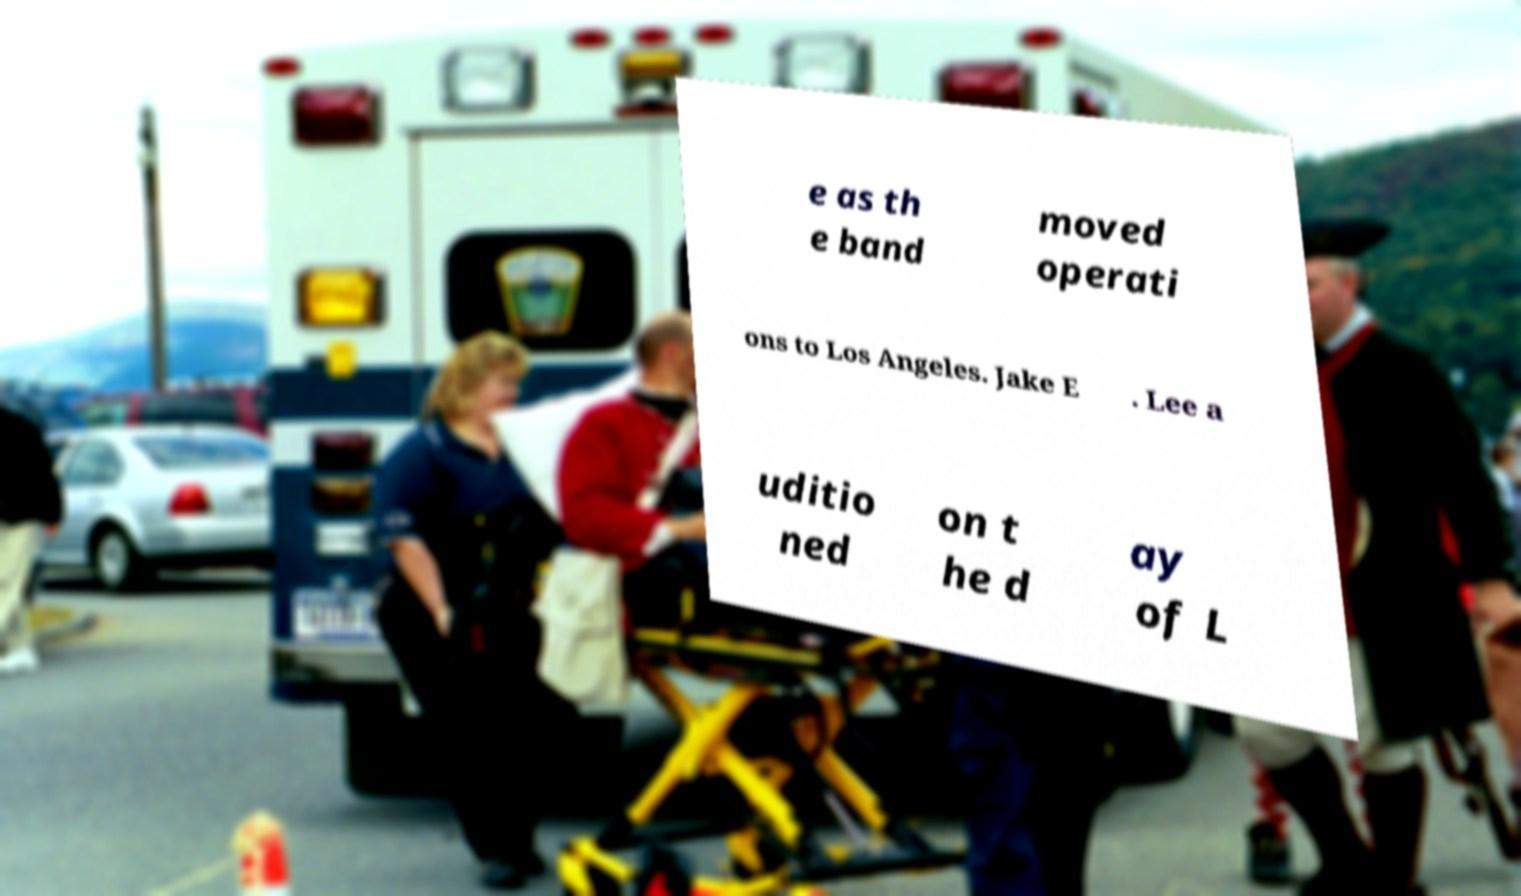Please identify and transcribe the text found in this image. e as th e band moved operati ons to Los Angeles. Jake E . Lee a uditio ned on t he d ay of L 